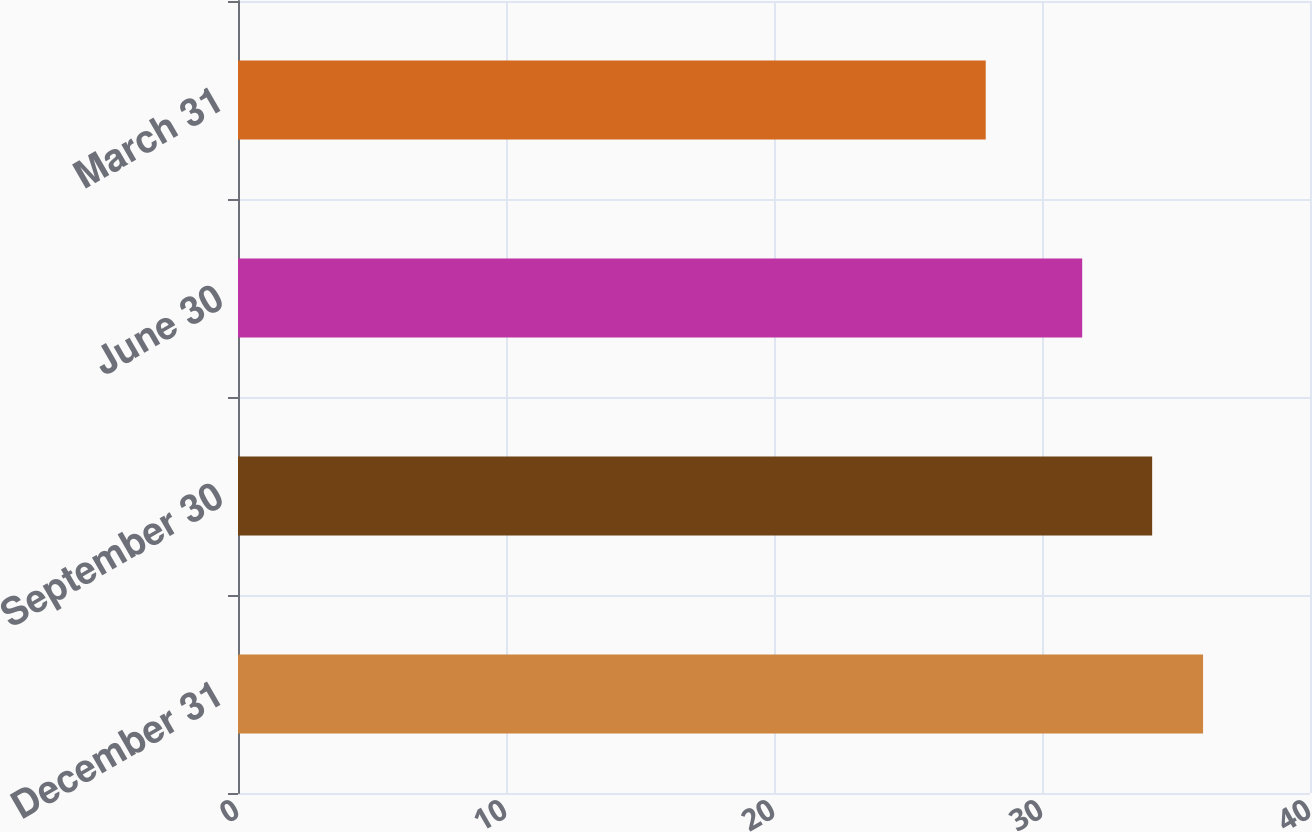Convert chart. <chart><loc_0><loc_0><loc_500><loc_500><bar_chart><fcel>December 31<fcel>September 30<fcel>June 30<fcel>March 31<nl><fcel>36.01<fcel>34.11<fcel>31.5<fcel>27.9<nl></chart> 